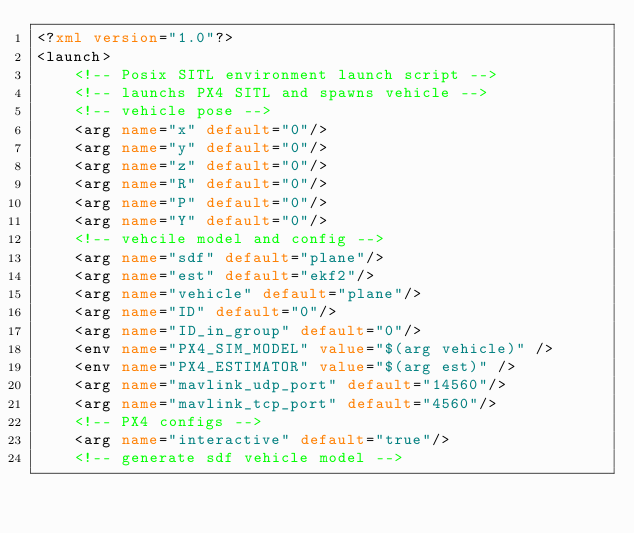<code> <loc_0><loc_0><loc_500><loc_500><_XML_><?xml version="1.0"?>
<launch>
    <!-- Posix SITL environment launch script -->
    <!-- launchs PX4 SITL and spawns vehicle -->
    <!-- vehicle pose -->
    <arg name="x" default="0"/>
    <arg name="y" default="0"/>
    <arg name="z" default="0"/>
    <arg name="R" default="0"/>
    <arg name="P" default="0"/>
    <arg name="Y" default="0"/>
    <!-- vehcile model and config -->
    <arg name="sdf" default="plane"/>
    <arg name="est" default="ekf2"/>
    <arg name="vehicle" default="plane"/>
    <arg name="ID" default="0"/>
    <arg name="ID_in_group" default="0"/>
    <env name="PX4_SIM_MODEL" value="$(arg vehicle)" />
    <env name="PX4_ESTIMATOR" value="$(arg est)" />
    <arg name="mavlink_udp_port" default="14560"/>
    <arg name="mavlink_tcp_port" default="4560"/>
    <!-- PX4 configs -->
    <arg name="interactive" default="true"/>
    <!-- generate sdf vehicle model --></code> 